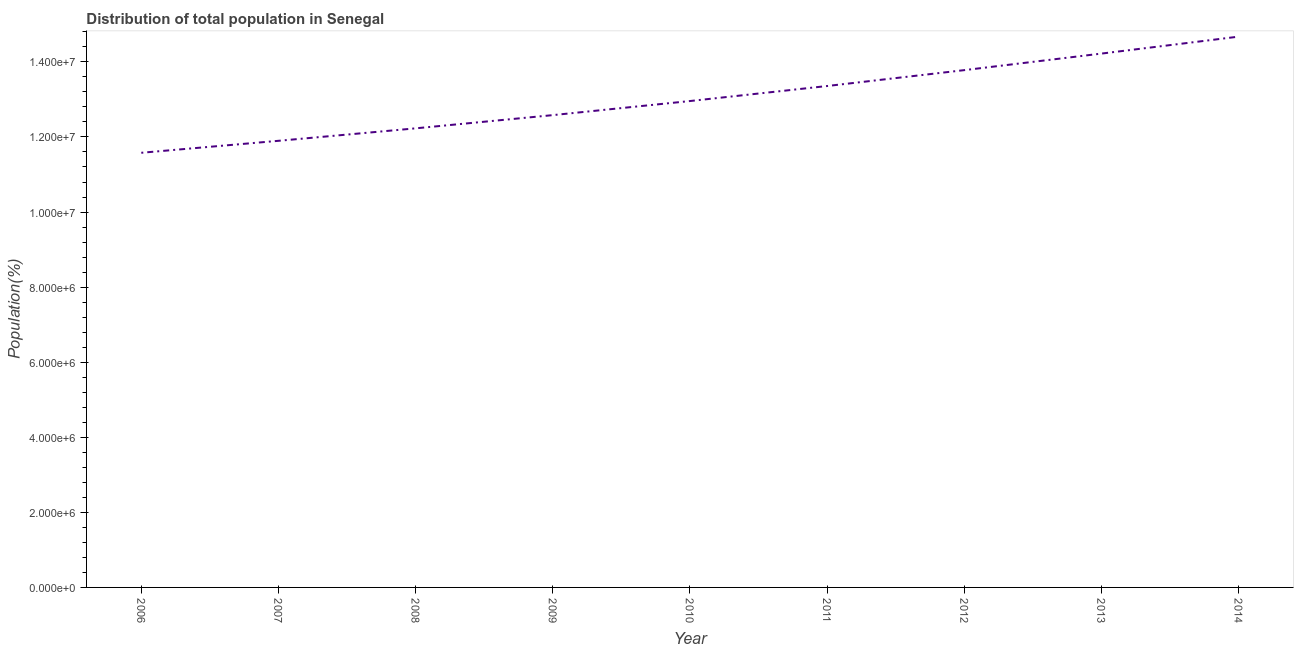What is the population in 2012?
Offer a very short reply. 1.38e+07. Across all years, what is the maximum population?
Your response must be concise. 1.47e+07. Across all years, what is the minimum population?
Provide a succinct answer. 1.16e+07. What is the sum of the population?
Ensure brevity in your answer.  1.17e+08. What is the difference between the population in 2006 and 2013?
Your response must be concise. -2.64e+06. What is the average population per year?
Make the answer very short. 1.30e+07. What is the median population?
Give a very brief answer. 1.30e+07. In how many years, is the population greater than 12000000 %?
Your answer should be very brief. 7. What is the ratio of the population in 2012 to that in 2013?
Your response must be concise. 0.97. Is the difference between the population in 2006 and 2008 greater than the difference between any two years?
Keep it short and to the point. No. What is the difference between the highest and the second highest population?
Give a very brief answer. 4.52e+05. Is the sum of the population in 2013 and 2014 greater than the maximum population across all years?
Ensure brevity in your answer.  Yes. What is the difference between the highest and the lowest population?
Give a very brief answer. 3.09e+06. In how many years, is the population greater than the average population taken over all years?
Keep it short and to the point. 4. How many lines are there?
Your response must be concise. 1. How many years are there in the graph?
Provide a short and direct response. 9. Does the graph contain any zero values?
Your answer should be compact. No. Does the graph contain grids?
Offer a terse response. No. What is the title of the graph?
Provide a succinct answer. Distribution of total population in Senegal . What is the label or title of the X-axis?
Make the answer very short. Year. What is the label or title of the Y-axis?
Offer a very short reply. Population(%). What is the Population(%) in 2006?
Make the answer very short. 1.16e+07. What is the Population(%) in 2007?
Your answer should be very brief. 1.19e+07. What is the Population(%) of 2008?
Ensure brevity in your answer.  1.22e+07. What is the Population(%) in 2009?
Offer a very short reply. 1.26e+07. What is the Population(%) of 2010?
Your answer should be compact. 1.30e+07. What is the Population(%) of 2011?
Offer a very short reply. 1.34e+07. What is the Population(%) of 2012?
Provide a succinct answer. 1.38e+07. What is the Population(%) in 2013?
Make the answer very short. 1.42e+07. What is the Population(%) of 2014?
Give a very brief answer. 1.47e+07. What is the difference between the Population(%) in 2006 and 2007?
Your response must be concise. -3.19e+05. What is the difference between the Population(%) in 2006 and 2008?
Give a very brief answer. -6.51e+05. What is the difference between the Population(%) in 2006 and 2009?
Your answer should be compact. -1.00e+06. What is the difference between the Population(%) in 2006 and 2010?
Offer a terse response. -1.38e+06. What is the difference between the Population(%) in 2006 and 2011?
Give a very brief answer. -1.78e+06. What is the difference between the Population(%) in 2006 and 2012?
Ensure brevity in your answer.  -2.20e+06. What is the difference between the Population(%) in 2006 and 2013?
Your answer should be compact. -2.64e+06. What is the difference between the Population(%) in 2006 and 2014?
Offer a terse response. -3.09e+06. What is the difference between the Population(%) in 2007 and 2008?
Your answer should be compact. -3.32e+05. What is the difference between the Population(%) in 2007 and 2009?
Provide a short and direct response. -6.84e+05. What is the difference between the Population(%) in 2007 and 2010?
Ensure brevity in your answer.  -1.06e+06. What is the difference between the Population(%) in 2007 and 2011?
Keep it short and to the point. -1.46e+06. What is the difference between the Population(%) in 2007 and 2012?
Your response must be concise. -1.88e+06. What is the difference between the Population(%) in 2007 and 2013?
Make the answer very short. -2.32e+06. What is the difference between the Population(%) in 2007 and 2014?
Offer a terse response. -2.78e+06. What is the difference between the Population(%) in 2008 and 2009?
Your answer should be very brief. -3.52e+05. What is the difference between the Population(%) in 2008 and 2010?
Your response must be concise. -7.27e+05. What is the difference between the Population(%) in 2008 and 2011?
Offer a very short reply. -1.13e+06. What is the difference between the Population(%) in 2008 and 2012?
Make the answer very short. -1.55e+06. What is the difference between the Population(%) in 2008 and 2013?
Ensure brevity in your answer.  -1.99e+06. What is the difference between the Population(%) in 2008 and 2014?
Give a very brief answer. -2.44e+06. What is the difference between the Population(%) in 2009 and 2010?
Offer a terse response. -3.75e+05. What is the difference between the Population(%) in 2009 and 2011?
Your answer should be very brief. -7.75e+05. What is the difference between the Population(%) in 2009 and 2012?
Ensure brevity in your answer.  -1.20e+06. What is the difference between the Population(%) in 2009 and 2013?
Your answer should be very brief. -1.64e+06. What is the difference between the Population(%) in 2009 and 2014?
Offer a terse response. -2.09e+06. What is the difference between the Population(%) in 2010 and 2011?
Your answer should be compact. -4.00e+05. What is the difference between the Population(%) in 2010 and 2012?
Offer a terse response. -8.23e+05. What is the difference between the Population(%) in 2010 and 2013?
Your answer should be very brief. -1.26e+06. What is the difference between the Population(%) in 2010 and 2014?
Provide a succinct answer. -1.72e+06. What is the difference between the Population(%) in 2011 and 2012?
Make the answer very short. -4.23e+05. What is the difference between the Population(%) in 2011 and 2013?
Offer a very short reply. -8.64e+05. What is the difference between the Population(%) in 2011 and 2014?
Provide a succinct answer. -1.32e+06. What is the difference between the Population(%) in 2012 and 2013?
Provide a succinct answer. -4.41e+05. What is the difference between the Population(%) in 2012 and 2014?
Ensure brevity in your answer.  -8.92e+05. What is the difference between the Population(%) in 2013 and 2014?
Your response must be concise. -4.52e+05. What is the ratio of the Population(%) in 2006 to that in 2008?
Provide a short and direct response. 0.95. What is the ratio of the Population(%) in 2006 to that in 2010?
Provide a succinct answer. 0.89. What is the ratio of the Population(%) in 2006 to that in 2011?
Provide a short and direct response. 0.87. What is the ratio of the Population(%) in 2006 to that in 2012?
Offer a very short reply. 0.84. What is the ratio of the Population(%) in 2006 to that in 2013?
Your answer should be compact. 0.81. What is the ratio of the Population(%) in 2006 to that in 2014?
Provide a succinct answer. 0.79. What is the ratio of the Population(%) in 2007 to that in 2009?
Ensure brevity in your answer.  0.95. What is the ratio of the Population(%) in 2007 to that in 2010?
Your answer should be very brief. 0.92. What is the ratio of the Population(%) in 2007 to that in 2011?
Give a very brief answer. 0.89. What is the ratio of the Population(%) in 2007 to that in 2012?
Your response must be concise. 0.86. What is the ratio of the Population(%) in 2007 to that in 2013?
Offer a very short reply. 0.84. What is the ratio of the Population(%) in 2007 to that in 2014?
Provide a succinct answer. 0.81. What is the ratio of the Population(%) in 2008 to that in 2010?
Make the answer very short. 0.94. What is the ratio of the Population(%) in 2008 to that in 2011?
Offer a very short reply. 0.92. What is the ratio of the Population(%) in 2008 to that in 2012?
Provide a short and direct response. 0.89. What is the ratio of the Population(%) in 2008 to that in 2013?
Keep it short and to the point. 0.86. What is the ratio of the Population(%) in 2008 to that in 2014?
Give a very brief answer. 0.83. What is the ratio of the Population(%) in 2009 to that in 2011?
Provide a short and direct response. 0.94. What is the ratio of the Population(%) in 2009 to that in 2012?
Offer a very short reply. 0.91. What is the ratio of the Population(%) in 2009 to that in 2013?
Provide a succinct answer. 0.89. What is the ratio of the Population(%) in 2009 to that in 2014?
Offer a very short reply. 0.86. What is the ratio of the Population(%) in 2010 to that in 2013?
Your answer should be compact. 0.91. What is the ratio of the Population(%) in 2010 to that in 2014?
Keep it short and to the point. 0.88. What is the ratio of the Population(%) in 2011 to that in 2013?
Your answer should be very brief. 0.94. What is the ratio of the Population(%) in 2011 to that in 2014?
Your response must be concise. 0.91. What is the ratio of the Population(%) in 2012 to that in 2013?
Give a very brief answer. 0.97. What is the ratio of the Population(%) in 2012 to that in 2014?
Your response must be concise. 0.94. What is the ratio of the Population(%) in 2013 to that in 2014?
Give a very brief answer. 0.97. 